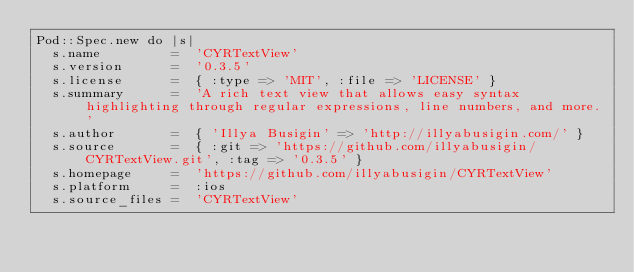Convert code to text. <code><loc_0><loc_0><loc_500><loc_500><_Ruby_>Pod::Spec.new do |s|
  s.name         =  'CYRTextView'
  s.version      =  '0.3.5'
  s.license      =  { :type => 'MIT', :file => 'LICENSE' }
  s.summary      =  'A rich text view that allows easy syntax highlighting through regular expressions, line numbers, and more.'
  s.author       =  { 'Illya Busigin' => 'http://illyabusigin.com/' }
  s.source       =  { :git => 'https://github.com/illyabusigin/CYRTextView.git', :tag => '0.3.5' }
  s.homepage     =  'https://github.com/illyabusigin/CYRTextView'
  s.platform     =  :ios
  s.source_files =  'CYRTextView'</code> 